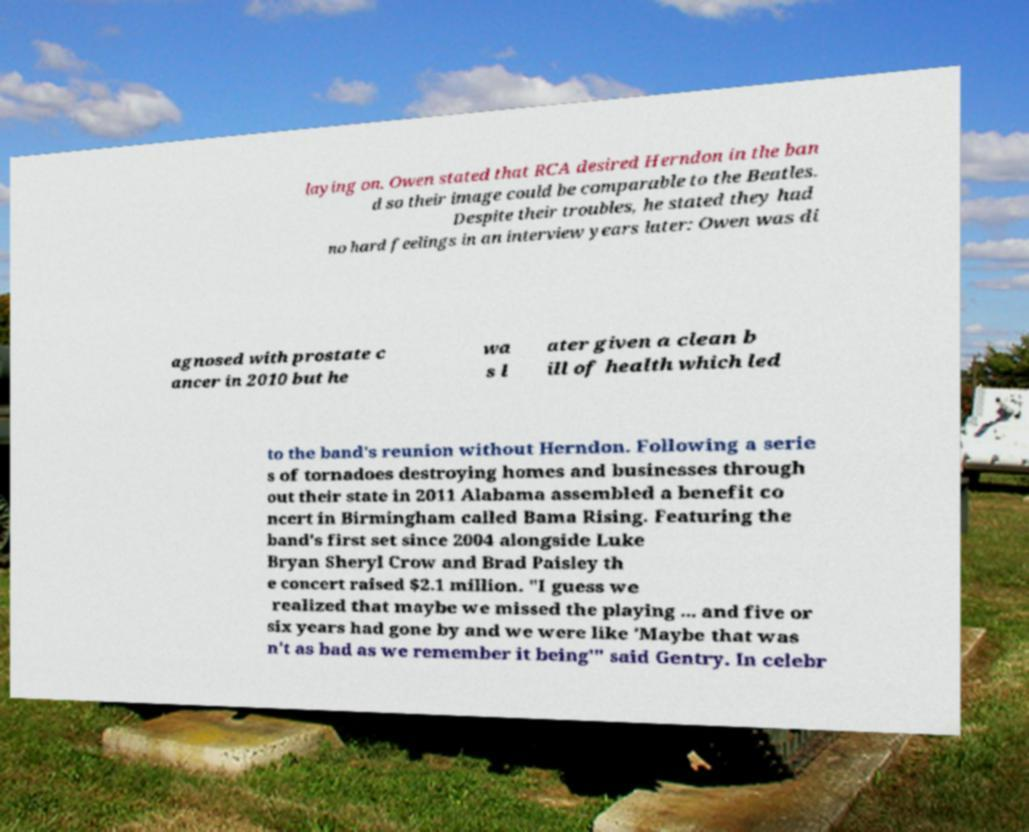For documentation purposes, I need the text within this image transcribed. Could you provide that? laying on. Owen stated that RCA desired Herndon in the ban d so their image could be comparable to the Beatles. Despite their troubles, he stated they had no hard feelings in an interview years later: Owen was di agnosed with prostate c ancer in 2010 but he wa s l ater given a clean b ill of health which led to the band's reunion without Herndon. Following a serie s of tornadoes destroying homes and businesses through out their state in 2011 Alabama assembled a benefit co ncert in Birmingham called Bama Rising. Featuring the band's first set since 2004 alongside Luke Bryan Sheryl Crow and Brad Paisley th e concert raised $2.1 million. "I guess we realized that maybe we missed the playing ... and five or six years had gone by and we were like 'Maybe that was n't as bad as we remember it being'" said Gentry. In celebr 